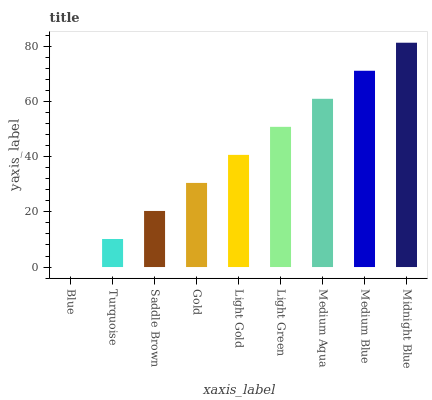Is Blue the minimum?
Answer yes or no. Yes. Is Midnight Blue the maximum?
Answer yes or no. Yes. Is Turquoise the minimum?
Answer yes or no. No. Is Turquoise the maximum?
Answer yes or no. No. Is Turquoise greater than Blue?
Answer yes or no. Yes. Is Blue less than Turquoise?
Answer yes or no. Yes. Is Blue greater than Turquoise?
Answer yes or no. No. Is Turquoise less than Blue?
Answer yes or no. No. Is Light Gold the high median?
Answer yes or no. Yes. Is Light Gold the low median?
Answer yes or no. Yes. Is Medium Aqua the high median?
Answer yes or no. No. Is Blue the low median?
Answer yes or no. No. 